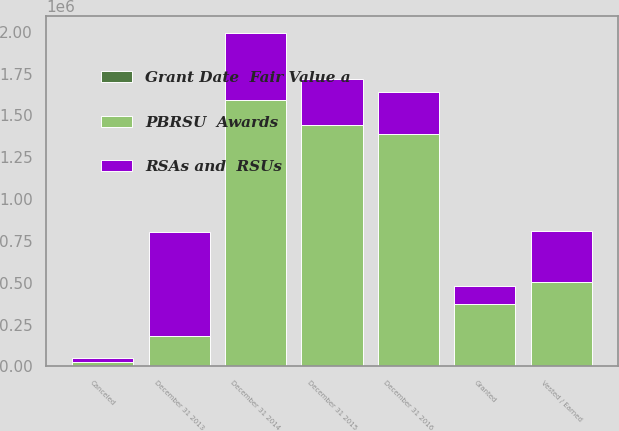Convert chart to OTSL. <chart><loc_0><loc_0><loc_500><loc_500><stacked_bar_chart><ecel><fcel>December 31 2013<fcel>Granted<fcel>Vested / Earned<fcel>Canceled<fcel>December 31 2014<fcel>December 31 2015<fcel>December 31 2016<nl><fcel>PBRSU  Awards<fcel>182026<fcel>373337<fcel>503324<fcel>27048<fcel>1.59323e+06<fcel>1.44419e+06<fcel>1.38669e+06<nl><fcel>Grant Date  Fair Value a<fcel>64.49<fcel>103.1<fcel>47.98<fcel>74.09<fcel>78.59<fcel>95.59<fcel>107.7<nl><fcel>RSAs and  RSUs<fcel>622021<fcel>109665<fcel>306830<fcel>23785<fcel>401071<fcel>273235<fcel>254387<nl></chart> 